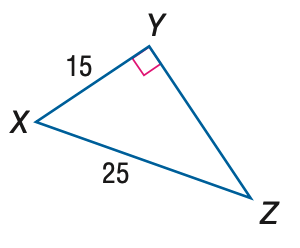Question: Find the measure of \angle Z to the nearest tenth.
Choices:
A. 31.0
B. 36.9
C. 53.1
D. 59.0
Answer with the letter. Answer: B 